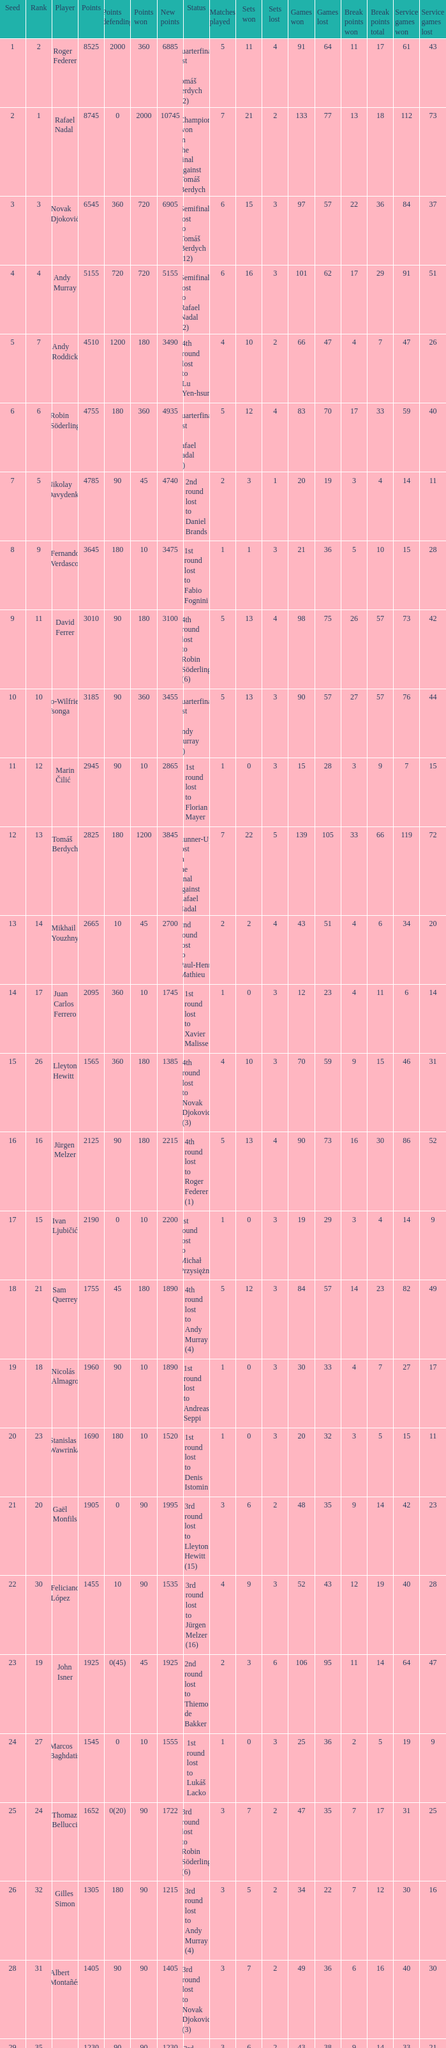Name the status for points 3185 Quarterfinals lost to Andy Murray (4). 